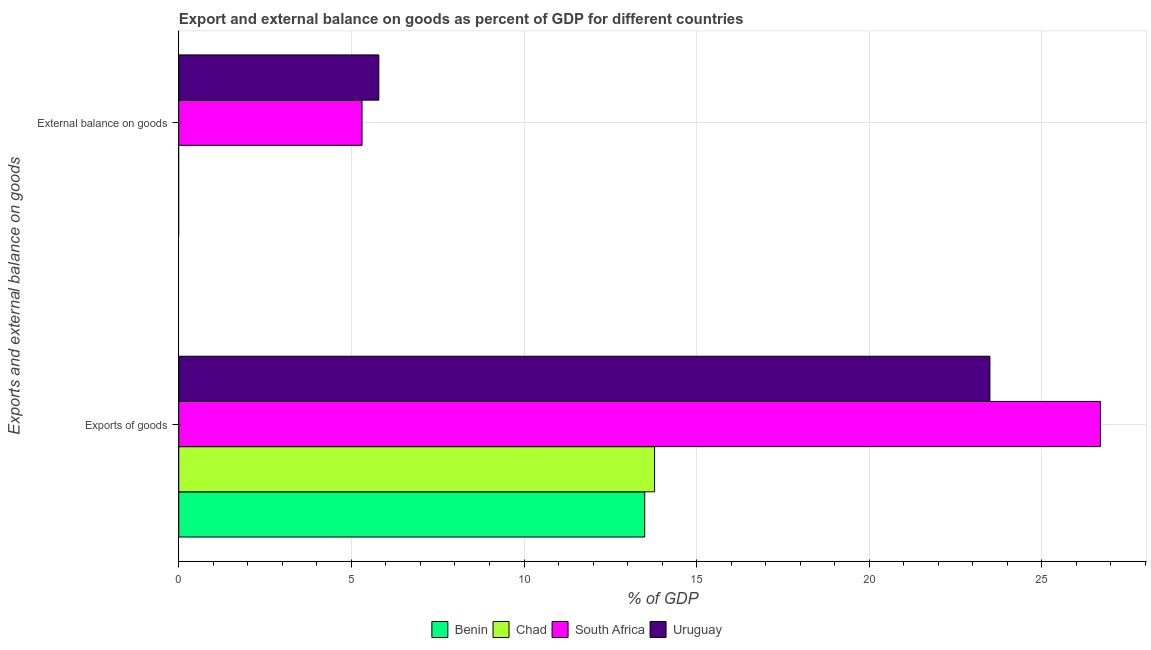Are the number of bars on each tick of the Y-axis equal?
Offer a very short reply. No. How many bars are there on the 1st tick from the top?
Offer a terse response. 2. What is the label of the 1st group of bars from the top?
Provide a short and direct response. External balance on goods. What is the external balance on goods as percentage of gdp in Chad?
Give a very brief answer. 0. Across all countries, what is the maximum export of goods as percentage of gdp?
Provide a succinct answer. 26.69. Across all countries, what is the minimum export of goods as percentage of gdp?
Offer a very short reply. 13.5. In which country was the external balance on goods as percentage of gdp maximum?
Your answer should be very brief. Uruguay. What is the total export of goods as percentage of gdp in the graph?
Keep it short and to the point. 77.47. What is the difference between the export of goods as percentage of gdp in Uruguay and that in Chad?
Make the answer very short. 9.71. What is the difference between the export of goods as percentage of gdp in Uruguay and the external balance on goods as percentage of gdp in Chad?
Provide a succinct answer. 23.49. What is the average export of goods as percentage of gdp per country?
Offer a very short reply. 19.37. What is the difference between the external balance on goods as percentage of gdp and export of goods as percentage of gdp in South Africa?
Provide a succinct answer. -21.39. In how many countries, is the export of goods as percentage of gdp greater than 21 %?
Give a very brief answer. 2. What is the ratio of the export of goods as percentage of gdp in South Africa to that in Uruguay?
Your answer should be compact. 1.14. In how many countries, is the external balance on goods as percentage of gdp greater than the average external balance on goods as percentage of gdp taken over all countries?
Make the answer very short. 2. Are all the bars in the graph horizontal?
Keep it short and to the point. Yes. How many countries are there in the graph?
Provide a short and direct response. 4. Are the values on the major ticks of X-axis written in scientific E-notation?
Ensure brevity in your answer.  No. Does the graph contain any zero values?
Provide a short and direct response. Yes. Does the graph contain grids?
Provide a short and direct response. Yes. How are the legend labels stacked?
Keep it short and to the point. Horizontal. What is the title of the graph?
Give a very brief answer. Export and external balance on goods as percent of GDP for different countries. What is the label or title of the X-axis?
Provide a succinct answer. % of GDP. What is the label or title of the Y-axis?
Offer a terse response. Exports and external balance on goods. What is the % of GDP in Benin in Exports of goods?
Your response must be concise. 13.5. What is the % of GDP in Chad in Exports of goods?
Offer a very short reply. 13.78. What is the % of GDP of South Africa in Exports of goods?
Ensure brevity in your answer.  26.69. What is the % of GDP in Uruguay in Exports of goods?
Keep it short and to the point. 23.49. What is the % of GDP of Chad in External balance on goods?
Your answer should be very brief. 0. What is the % of GDP of South Africa in External balance on goods?
Your answer should be very brief. 5.31. What is the % of GDP in Uruguay in External balance on goods?
Your response must be concise. 5.79. Across all Exports and external balance on goods, what is the maximum % of GDP of Benin?
Make the answer very short. 13.5. Across all Exports and external balance on goods, what is the maximum % of GDP in Chad?
Provide a succinct answer. 13.78. Across all Exports and external balance on goods, what is the maximum % of GDP in South Africa?
Give a very brief answer. 26.69. Across all Exports and external balance on goods, what is the maximum % of GDP in Uruguay?
Ensure brevity in your answer.  23.49. Across all Exports and external balance on goods, what is the minimum % of GDP of Benin?
Provide a succinct answer. 0. Across all Exports and external balance on goods, what is the minimum % of GDP in South Africa?
Keep it short and to the point. 5.31. Across all Exports and external balance on goods, what is the minimum % of GDP of Uruguay?
Provide a succinct answer. 5.79. What is the total % of GDP of Benin in the graph?
Ensure brevity in your answer.  13.5. What is the total % of GDP of Chad in the graph?
Keep it short and to the point. 13.78. What is the total % of GDP in South Africa in the graph?
Provide a short and direct response. 32. What is the total % of GDP in Uruguay in the graph?
Offer a very short reply. 29.29. What is the difference between the % of GDP in South Africa in Exports of goods and that in External balance on goods?
Give a very brief answer. 21.39. What is the difference between the % of GDP of Uruguay in Exports of goods and that in External balance on goods?
Your response must be concise. 17.7. What is the difference between the % of GDP of Benin in Exports of goods and the % of GDP of South Africa in External balance on goods?
Provide a succinct answer. 8.19. What is the difference between the % of GDP of Benin in Exports of goods and the % of GDP of Uruguay in External balance on goods?
Your response must be concise. 7.7. What is the difference between the % of GDP of Chad in Exports of goods and the % of GDP of South Africa in External balance on goods?
Provide a succinct answer. 8.47. What is the difference between the % of GDP of Chad in Exports of goods and the % of GDP of Uruguay in External balance on goods?
Provide a succinct answer. 7.99. What is the difference between the % of GDP of South Africa in Exports of goods and the % of GDP of Uruguay in External balance on goods?
Make the answer very short. 20.9. What is the average % of GDP of Benin per Exports and external balance on goods?
Your answer should be compact. 6.75. What is the average % of GDP in Chad per Exports and external balance on goods?
Give a very brief answer. 6.89. What is the average % of GDP in South Africa per Exports and external balance on goods?
Make the answer very short. 16. What is the average % of GDP in Uruguay per Exports and external balance on goods?
Offer a very short reply. 14.64. What is the difference between the % of GDP of Benin and % of GDP of Chad in Exports of goods?
Offer a very short reply. -0.29. What is the difference between the % of GDP of Benin and % of GDP of South Africa in Exports of goods?
Make the answer very short. -13.2. What is the difference between the % of GDP of Benin and % of GDP of Uruguay in Exports of goods?
Keep it short and to the point. -10. What is the difference between the % of GDP of Chad and % of GDP of South Africa in Exports of goods?
Your answer should be very brief. -12.91. What is the difference between the % of GDP in Chad and % of GDP in Uruguay in Exports of goods?
Your answer should be very brief. -9.71. What is the difference between the % of GDP of South Africa and % of GDP of Uruguay in Exports of goods?
Offer a very short reply. 3.2. What is the difference between the % of GDP in South Africa and % of GDP in Uruguay in External balance on goods?
Offer a terse response. -0.49. What is the ratio of the % of GDP of South Africa in Exports of goods to that in External balance on goods?
Your answer should be compact. 5.03. What is the ratio of the % of GDP in Uruguay in Exports of goods to that in External balance on goods?
Your answer should be very brief. 4.05. What is the difference between the highest and the second highest % of GDP in South Africa?
Make the answer very short. 21.39. What is the difference between the highest and the second highest % of GDP of Uruguay?
Provide a succinct answer. 17.7. What is the difference between the highest and the lowest % of GDP of Benin?
Make the answer very short. 13.5. What is the difference between the highest and the lowest % of GDP in Chad?
Your answer should be very brief. 13.78. What is the difference between the highest and the lowest % of GDP in South Africa?
Your answer should be very brief. 21.39. What is the difference between the highest and the lowest % of GDP in Uruguay?
Give a very brief answer. 17.7. 